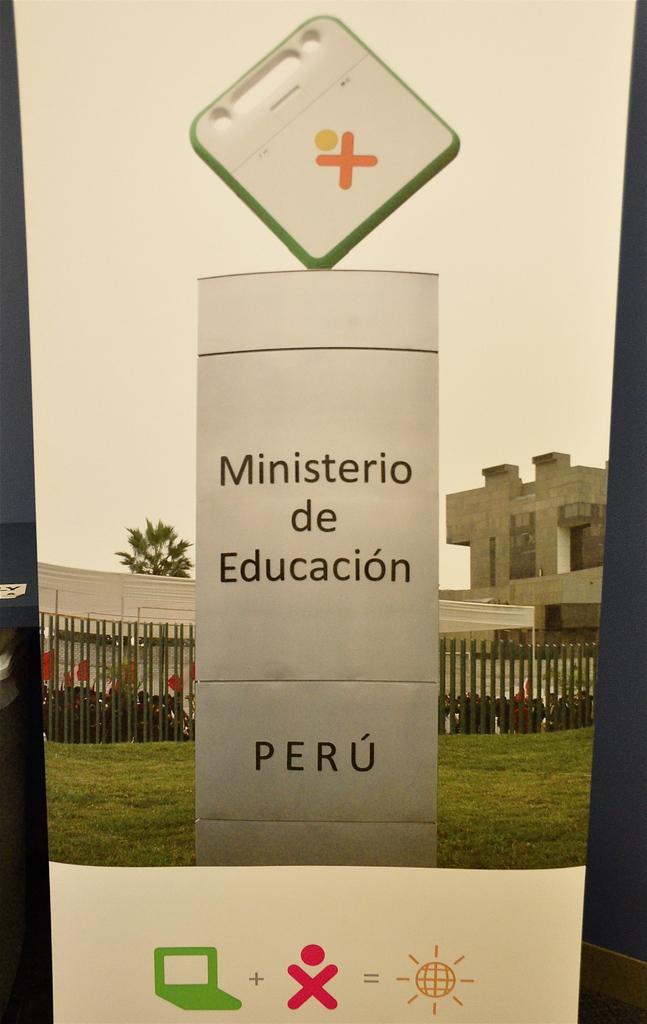In one or two sentences, can you explain what this image depicts? In this image there is a building, in front of building there are vehicles, fence, at the top there is the sky and tree visible in the middle, in the foreground there might be a board, on which there is a text, symbols visible at the bottom, at the top of the board there is small board visible there is a symbol. 